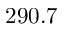<formula> <loc_0><loc_0><loc_500><loc_500>2 9 0 . 7</formula> 